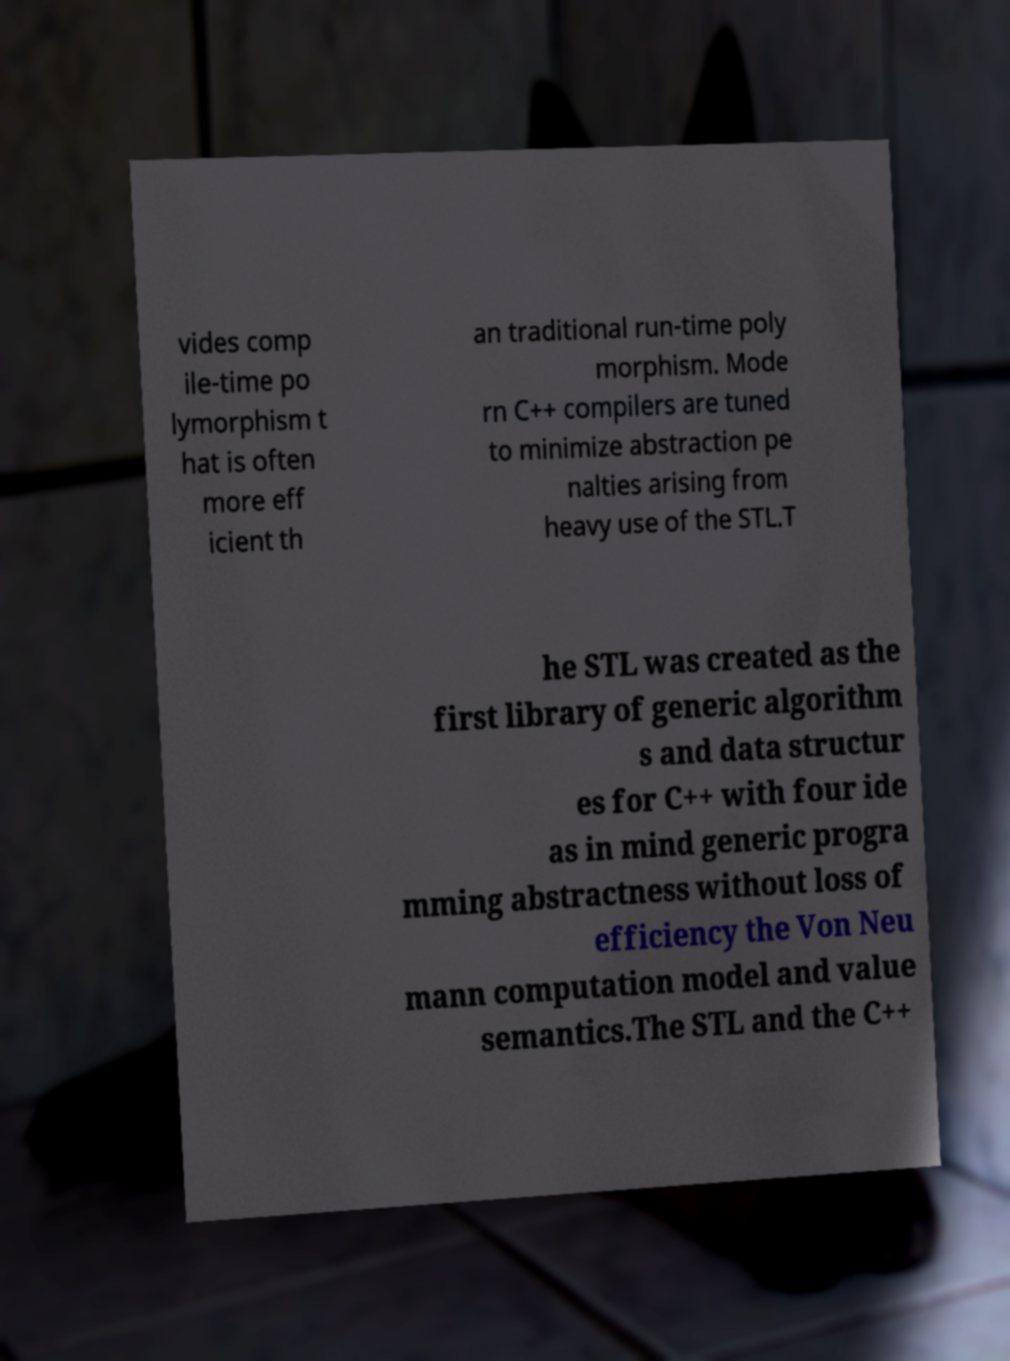Please identify and transcribe the text found in this image. vides comp ile-time po lymorphism t hat is often more eff icient th an traditional run-time poly morphism. Mode rn C++ compilers are tuned to minimize abstraction pe nalties arising from heavy use of the STL.T he STL was created as the first library of generic algorithm s and data structur es for C++ with four ide as in mind generic progra mming abstractness without loss of efficiency the Von Neu mann computation model and value semantics.The STL and the C++ 